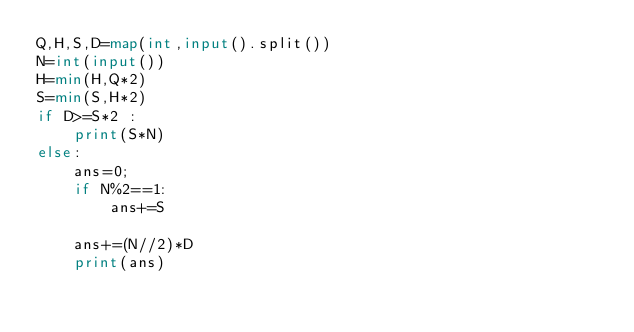Convert code to text. <code><loc_0><loc_0><loc_500><loc_500><_Python_>Q,H,S,D=map(int,input().split())
N=int(input())
H=min(H,Q*2)
S=min(S,H*2)
if D>=S*2 :
    print(S*N)
else:
    ans=0;
    if N%2==1:
        ans+=S
    
    ans+=(N//2)*D
    print(ans)</code> 